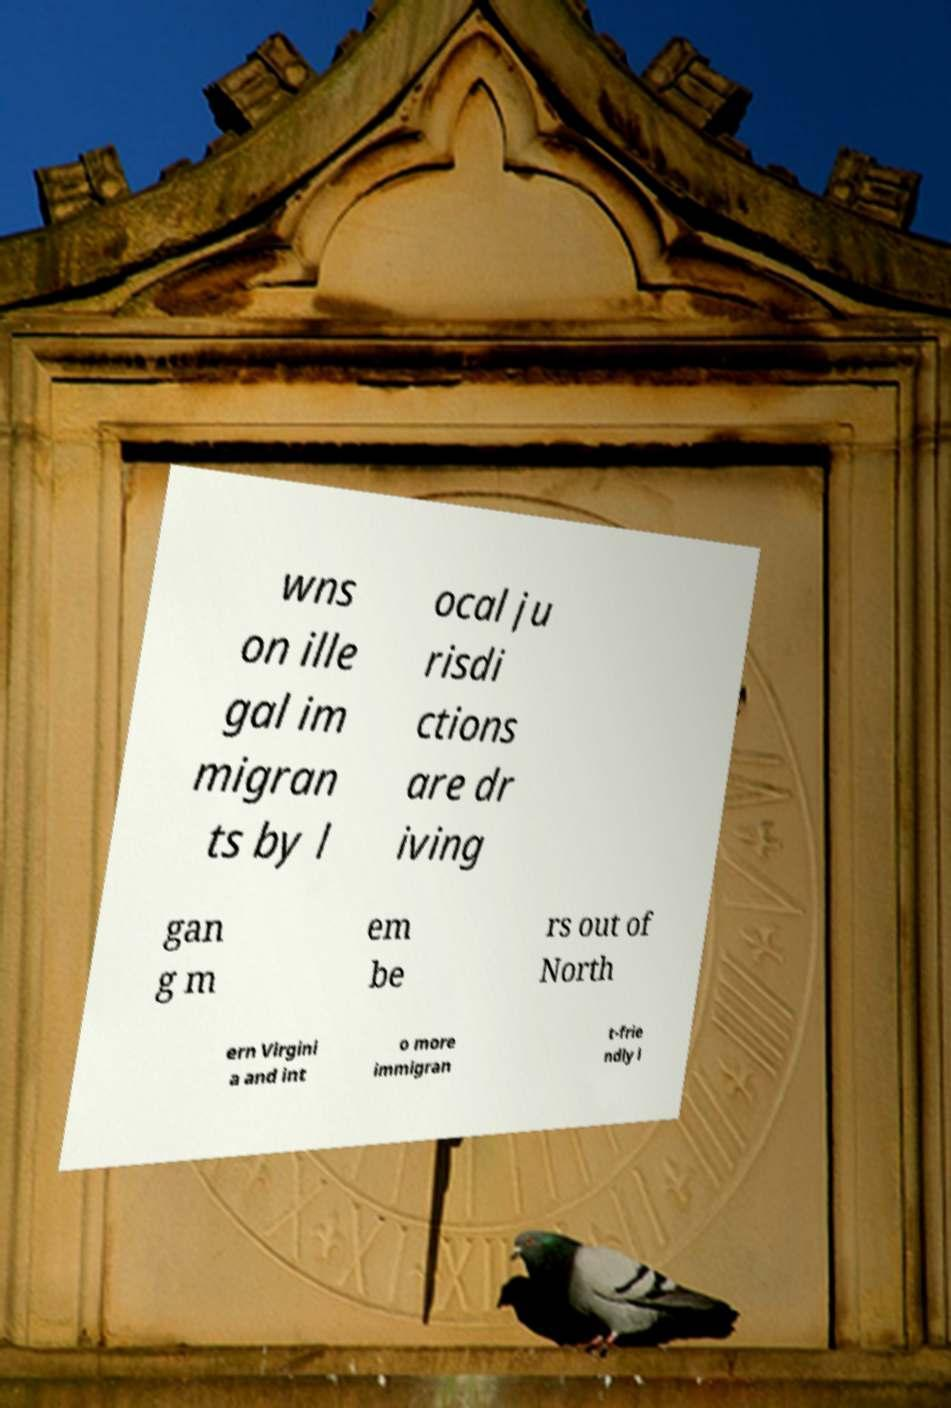Please identify and transcribe the text found in this image. wns on ille gal im migran ts by l ocal ju risdi ctions are dr iving gan g m em be rs out of North ern Virgini a and int o more immigran t-frie ndly l 